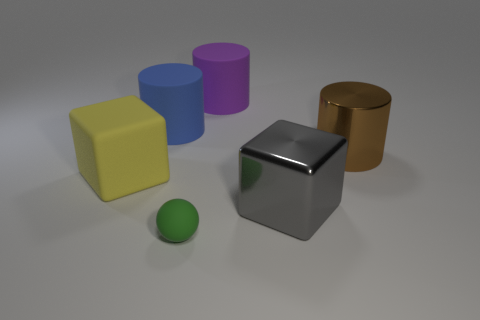Add 1 tiny red cubes. How many objects exist? 7 Subtract all balls. How many objects are left? 5 Add 4 big gray things. How many big gray things exist? 5 Subtract 1 blue cylinders. How many objects are left? 5 Subtract all big yellow objects. Subtract all tiny green objects. How many objects are left? 4 Add 4 tiny green rubber objects. How many tiny green rubber objects are left? 5 